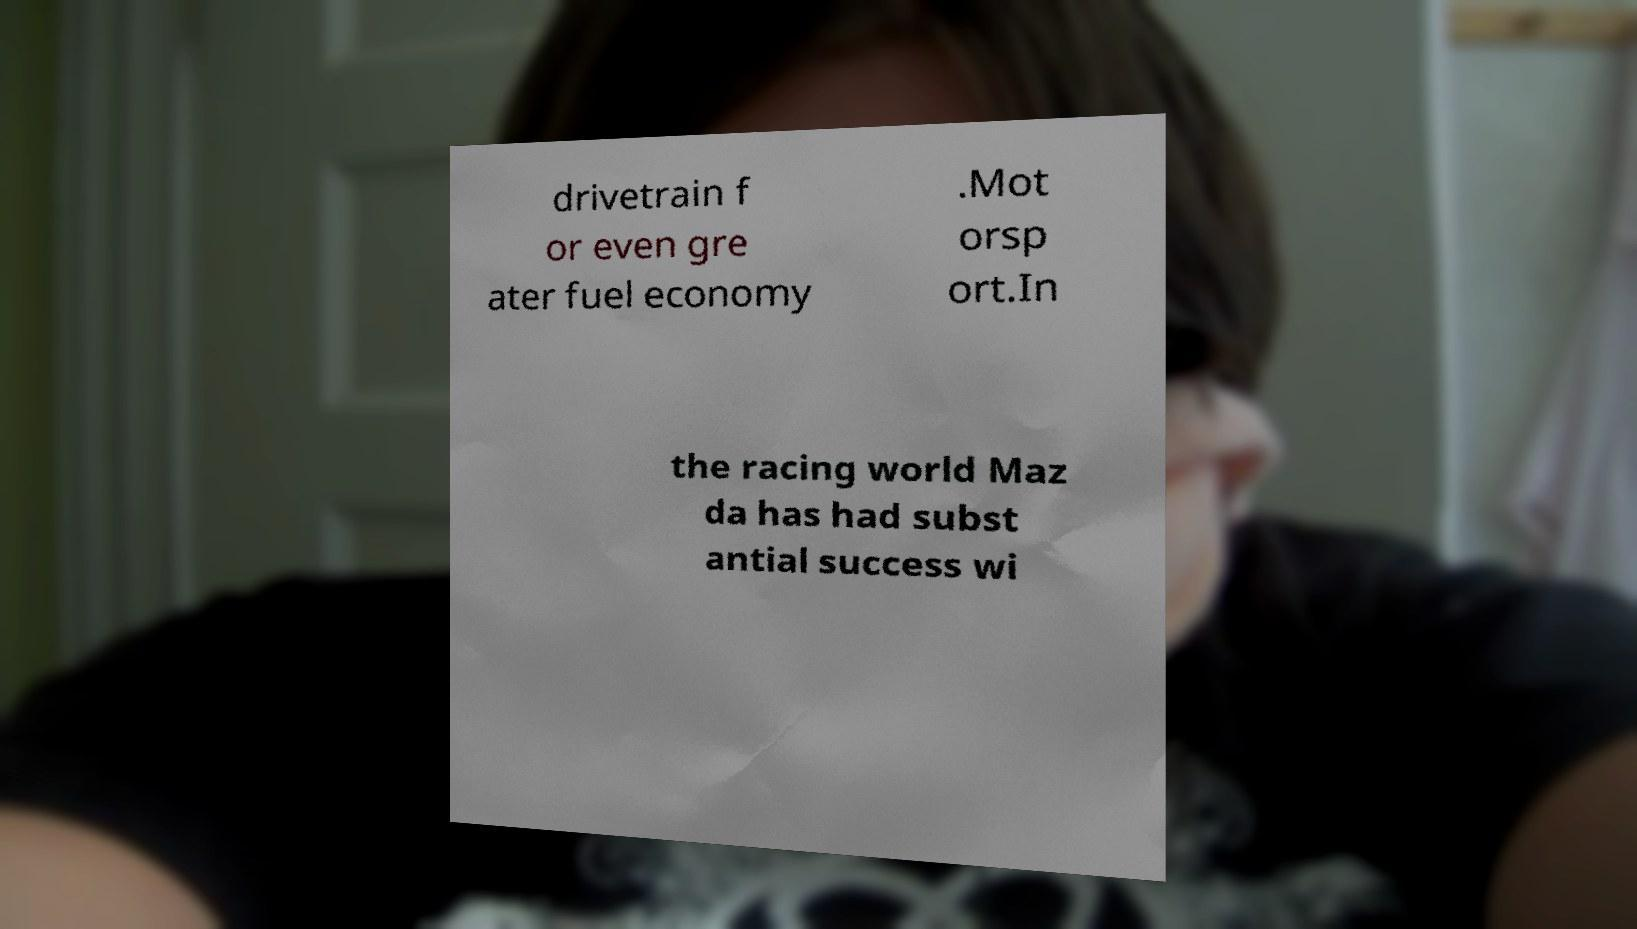There's text embedded in this image that I need extracted. Can you transcribe it verbatim? drivetrain f or even gre ater fuel economy .Mot orsp ort.In the racing world Maz da has had subst antial success wi 